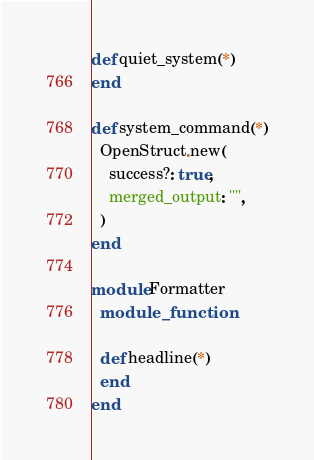<code> <loc_0><loc_0><loc_500><loc_500><_Ruby_>def quiet_system(*)
end

def system_command(*)
  OpenStruct.new(
    success?: true,
    merged_output: "",
  )
end

module Formatter
  module_function

  def headline(*)
  end
end
</code> 